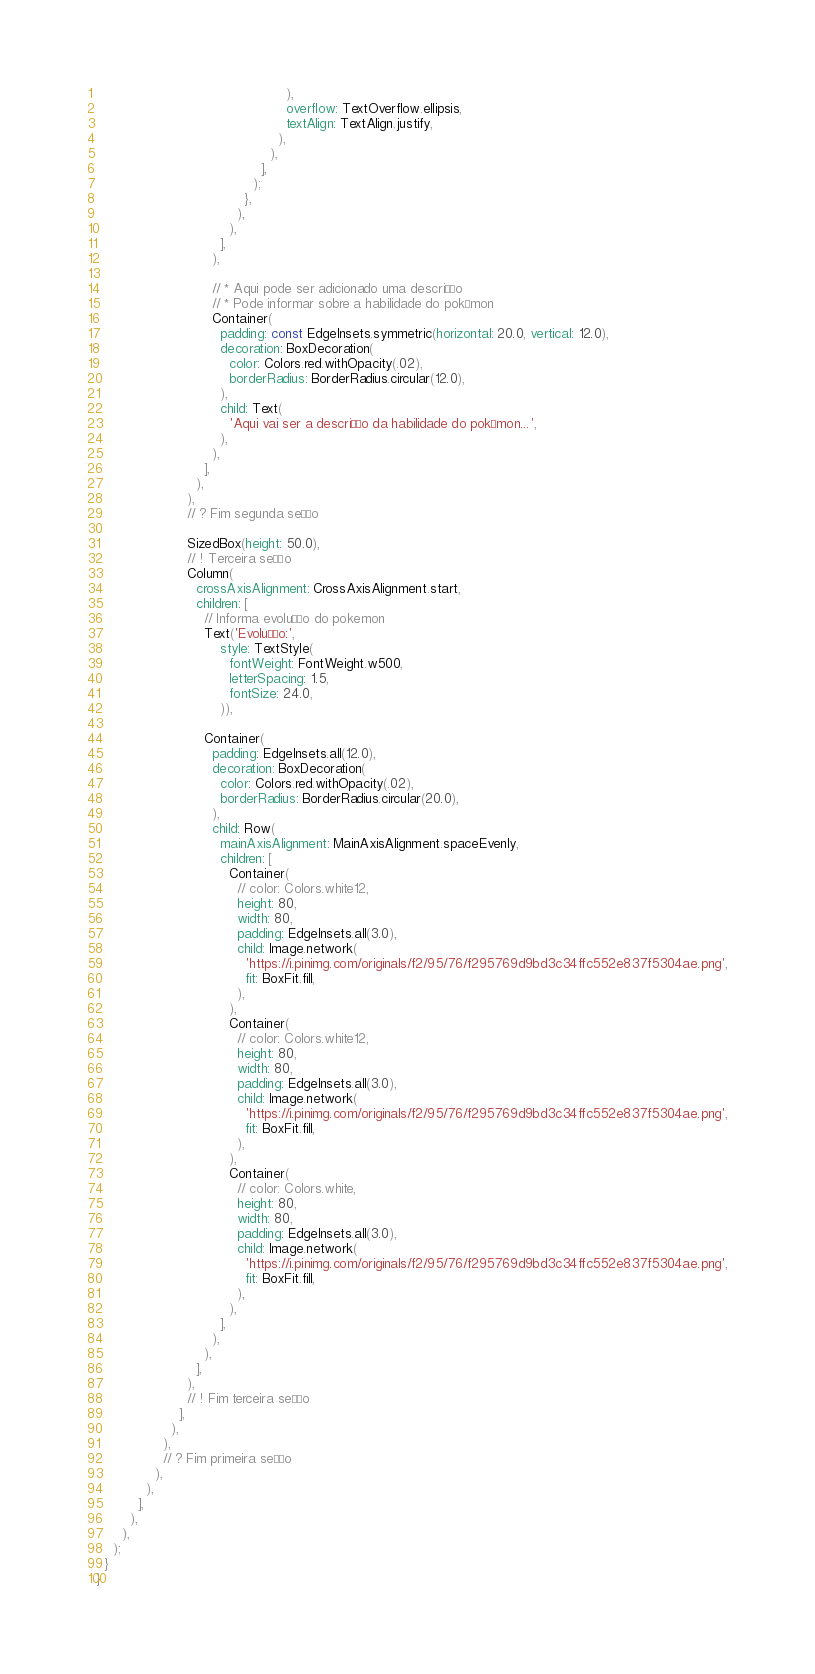Convert code to text. <code><loc_0><loc_0><loc_500><loc_500><_Dart_>                                              ),
                                              overflow: TextOverflow.ellipsis,
                                              textAlign: TextAlign.justify,
                                            ),
                                          ),
                                        ],
                                      );
                                    },
                                  ),
                                ),
                              ],
                            ),

                            // * Aqui pode ser adicionado uma descrição
                            // * Pode informar sobre a habilidade do pokémon
                            Container(
                              padding: const EdgeInsets.symmetric(horizontal: 20.0, vertical: 12.0),
                              decoration: BoxDecoration(
                                color: Colors.red.withOpacity(.02),
                                borderRadius: BorderRadius.circular(12.0),
                              ),
                              child: Text(
                                'Aqui vai ser a descrição da habilidade do pokémon...',
                              ),
                            ),
                          ],
                        ),
                      ),
                      // ? Fim segunda seção

                      SizedBox(height: 50.0),
                      // ! Terceira seção
                      Column(
                        crossAxisAlignment: CrossAxisAlignment.start,
                        children: [
                          // Informa evolução do pokemon
                          Text('Evolução:',
                              style: TextStyle(
                                fontWeight: FontWeight.w500,
                                letterSpacing: 1.5,
                                fontSize: 24.0,
                              )),

                          Container(
                            padding: EdgeInsets.all(12.0),
                            decoration: BoxDecoration(
                              color: Colors.red.withOpacity(.02),
                              borderRadius: BorderRadius.circular(20.0),
                            ),
                            child: Row(
                              mainAxisAlignment: MainAxisAlignment.spaceEvenly,
                              children: [
                                Container(
                                  // color: Colors.white12,
                                  height: 80,
                                  width: 80,
                                  padding: EdgeInsets.all(3.0),
                                  child: Image.network(
                                    'https://i.pinimg.com/originals/f2/95/76/f295769d9bd3c34ffc552e837f5304ae.png',
                                    fit: BoxFit.fill,
                                  ),
                                ),
                                Container(
                                  // color: Colors.white12,
                                  height: 80,
                                  width: 80,
                                  padding: EdgeInsets.all(3.0),
                                  child: Image.network(
                                    'https://i.pinimg.com/originals/f2/95/76/f295769d9bd3c34ffc552e837f5304ae.png',
                                    fit: BoxFit.fill,
                                  ),
                                ),
                                Container(
                                  // color: Colors.white,
                                  height: 80,
                                  width: 80,
                                  padding: EdgeInsets.all(3.0),
                                  child: Image.network(
                                    'https://i.pinimg.com/originals/f2/95/76/f295769d9bd3c34ffc552e837f5304ae.png',
                                    fit: BoxFit.fill,
                                  ),
                                ),
                              ],
                            ),
                          ),
                        ],
                      ),
                      // ! Fim terceira seção
                    ],
                  ),
                ),
                // ? Fim primeira seção
              ),
            ),
          ],
        ),
      ),
    );
  }
}
</code> 